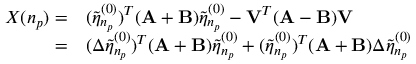Convert formula to latex. <formula><loc_0><loc_0><loc_500><loc_500>\begin{array} { r l } { X ( n _ { p } ) = } & ( \tilde { \eta } _ { n _ { p } } ^ { ( 0 ) } ) ^ { T } ( A + B ) \tilde { \eta } _ { n _ { p } } ^ { ( 0 ) } - V ^ { T } ( A - B ) V } \\ { = } & ( \Delta \tilde { \eta } _ { n _ { p } } ^ { ( 0 ) } ) ^ { T } ( A + B ) \tilde { \eta } _ { n _ { p } } ^ { ( 0 ) } + ( \tilde { \eta } _ { n _ { p } } ^ { ( 0 ) } ) ^ { T } ( A + B ) \Delta \tilde { \eta } _ { n _ { p } } ^ { ( 0 ) } } \end{array}</formula> 